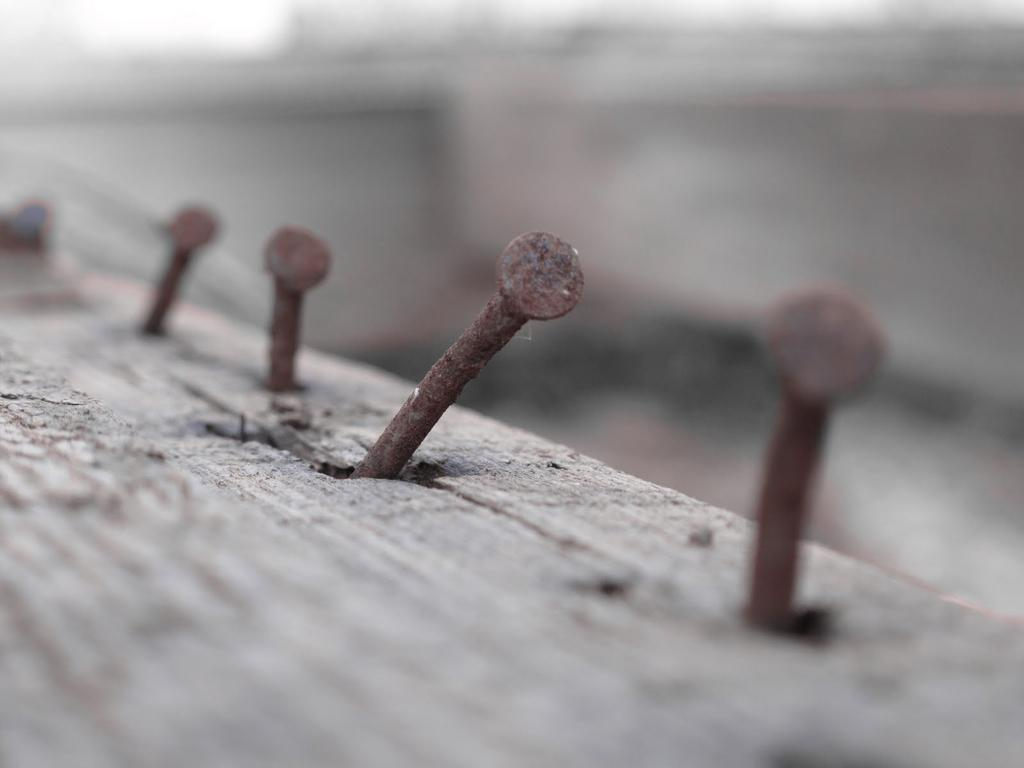What objects can be seen on the wooden surface in the image? There are screws on a wooden surface in the image. Can you describe the background of the image? The background of the image is blurry. What type of berry is growing on the wooden surface in the image? There are no berries present on the wooden surface in the image; it only contains screws. 